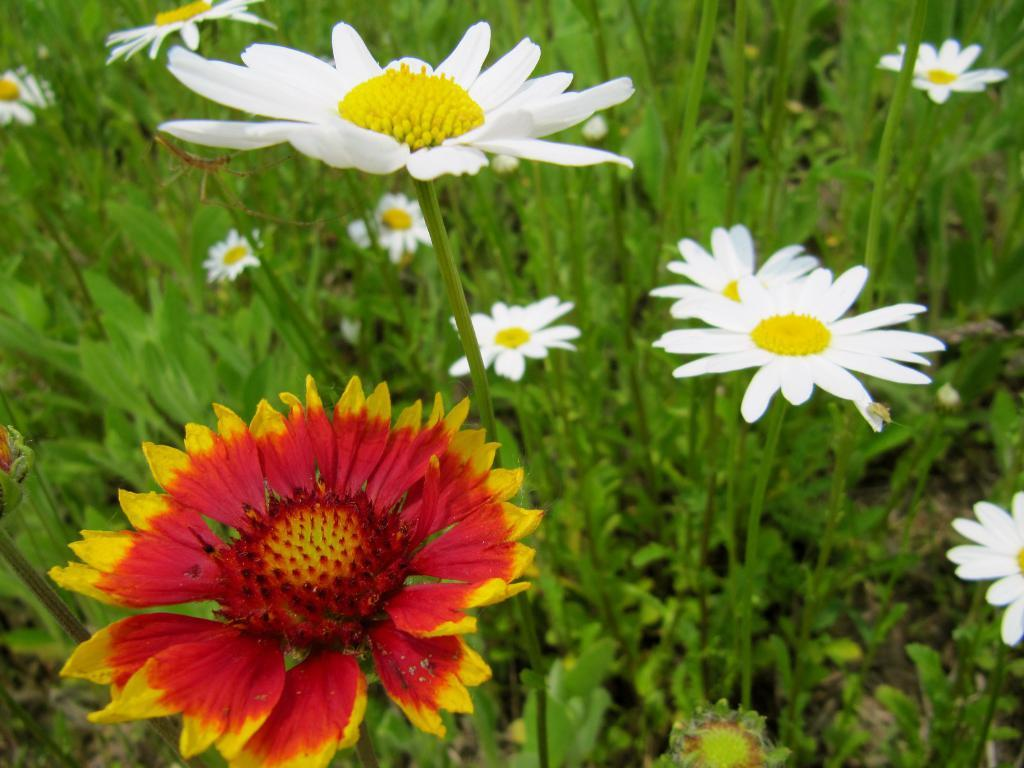What colors are the flowers in the image? The flowers in the image have white, red, and yellow colors. What other features do the flowers have besides their colors? The flowers have leaves. Are there any flowers with a combination of colors? Yes, there are flowers with both white and red, yellow colors. Can you describe anything else visible in the image? There appears to be an insect in the image. What time of day is it in the image based on the presence of smoke? There is no smoke present in the image, so it is not possible to determine the time of day based on that. 